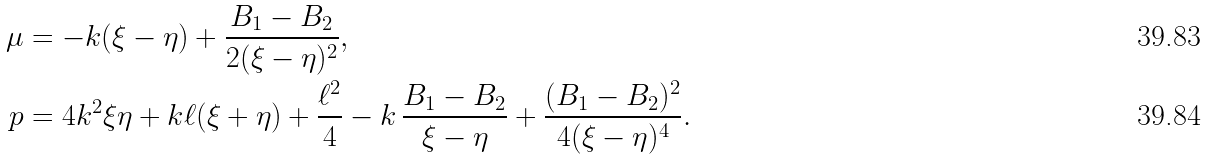Convert formula to latex. <formula><loc_0><loc_0><loc_500><loc_500>\mu & = - k ( \xi - \eta ) + \frac { B _ { 1 } - B _ { 2 } } { 2 ( \xi - \eta ) ^ { 2 } } , \\ p & = 4 k ^ { 2 } \xi \eta + k \ell ( \xi + \eta ) + \frac { \ell ^ { 2 } } { 4 } - k \, \frac { B _ { 1 } - B _ { 2 } } { \xi - \eta } + \frac { ( B _ { 1 } - B _ { 2 } ) ^ { 2 } } { 4 ( \xi - \eta ) ^ { 4 } } .</formula> 